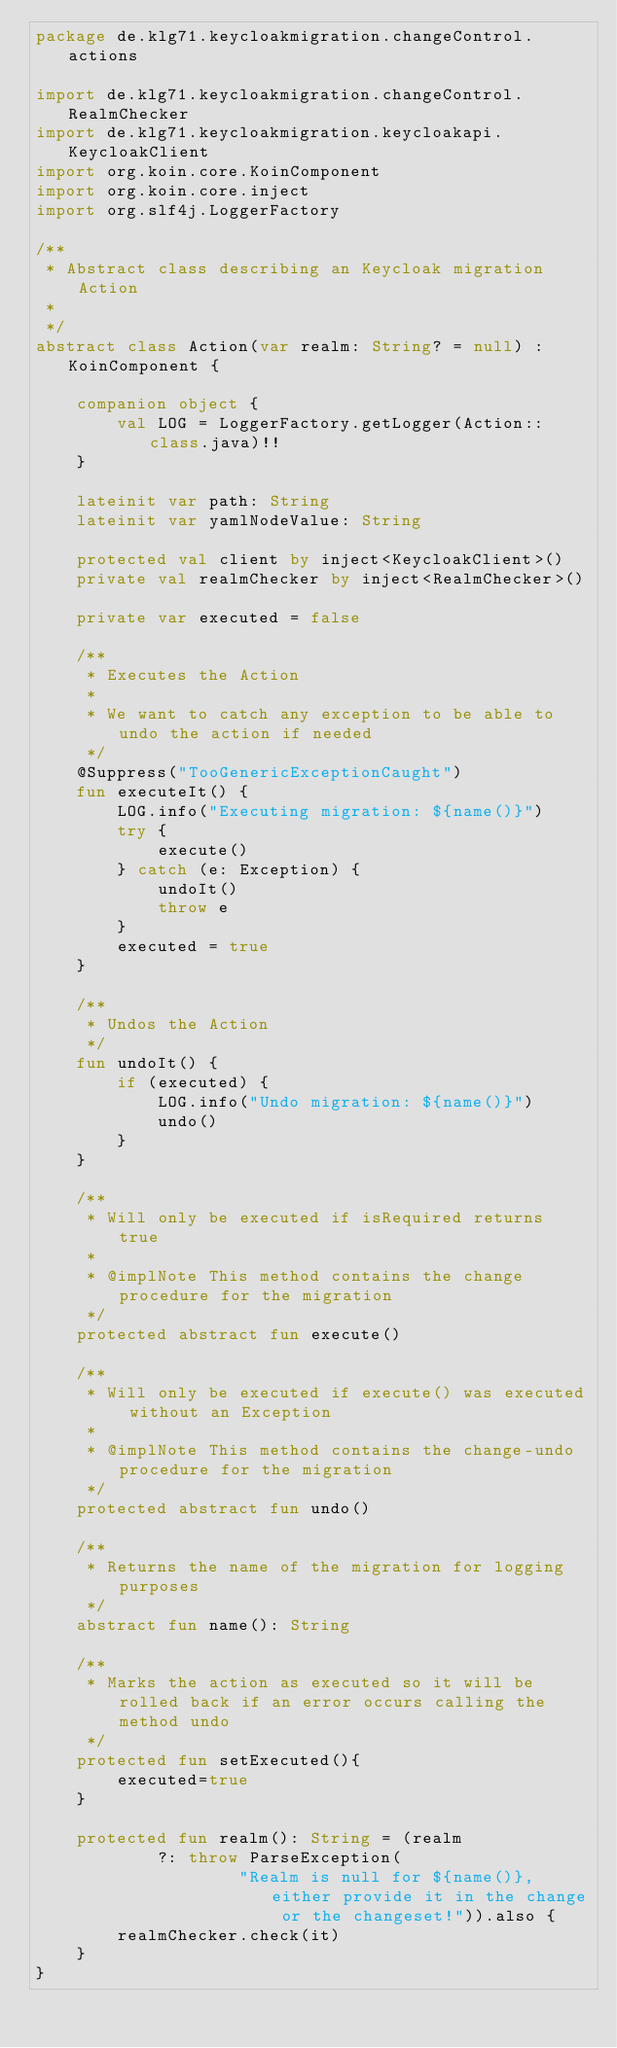<code> <loc_0><loc_0><loc_500><loc_500><_Kotlin_>package de.klg71.keycloakmigration.changeControl.actions

import de.klg71.keycloakmigration.changeControl.RealmChecker
import de.klg71.keycloakmigration.keycloakapi.KeycloakClient
import org.koin.core.KoinComponent
import org.koin.core.inject
import org.slf4j.LoggerFactory

/**
 * Abstract class describing an Keycloak migration Action
 *
 */
abstract class Action(var realm: String? = null) : KoinComponent {

    companion object {
        val LOG = LoggerFactory.getLogger(Action::class.java)!!
    }

    lateinit var path: String
    lateinit var yamlNodeValue: String

    protected val client by inject<KeycloakClient>()
    private val realmChecker by inject<RealmChecker>()

    private var executed = false

    /**
     * Executes the Action
     *
     * We want to catch any exception to be able to undo the action if needed
     */
    @Suppress("TooGenericExceptionCaught")
    fun executeIt() {
        LOG.info("Executing migration: ${name()}")
        try {
            execute()
        } catch (e: Exception) {
            undoIt()
            throw e
        }
        executed = true
    }

    /**
     * Undos the Action
     */
    fun undoIt() {
        if (executed) {
            LOG.info("Undo migration: ${name()}")
            undo()
        }
    }

    /**
     * Will only be executed if isRequired returns true
     *
     * @implNote This method contains the change procedure for the migration
     */
    protected abstract fun execute()

    /**
     * Will only be executed if execute() was executed without an Exception
     *
     * @implNote This method contains the change-undo procedure for the migration
     */
    protected abstract fun undo()

    /**
     * Returns the name of the migration for logging purposes
     */
    abstract fun name(): String

    /**
     * Marks the action as executed so it will be rolled back if an error occurs calling the method undo
     */
    protected fun setExecuted(){
        executed=true
    }

    protected fun realm(): String = (realm
            ?: throw ParseException(
                    "Realm is null for ${name()}, either provide it in the change or the changeset!")).also {
        realmChecker.check(it)
    }
}
</code> 